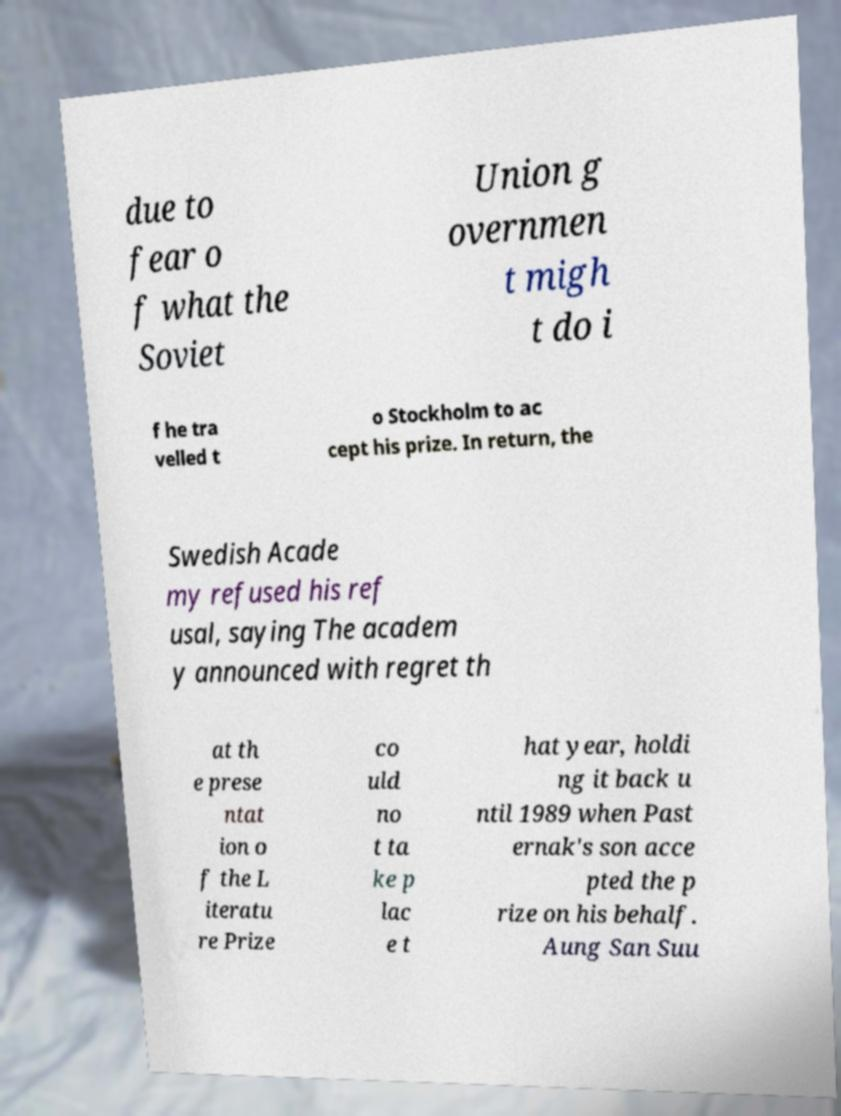I need the written content from this picture converted into text. Can you do that? due to fear o f what the Soviet Union g overnmen t migh t do i f he tra velled t o Stockholm to ac cept his prize. In return, the Swedish Acade my refused his ref usal, saying The academ y announced with regret th at th e prese ntat ion o f the L iteratu re Prize co uld no t ta ke p lac e t hat year, holdi ng it back u ntil 1989 when Past ernak's son acce pted the p rize on his behalf. Aung San Suu 